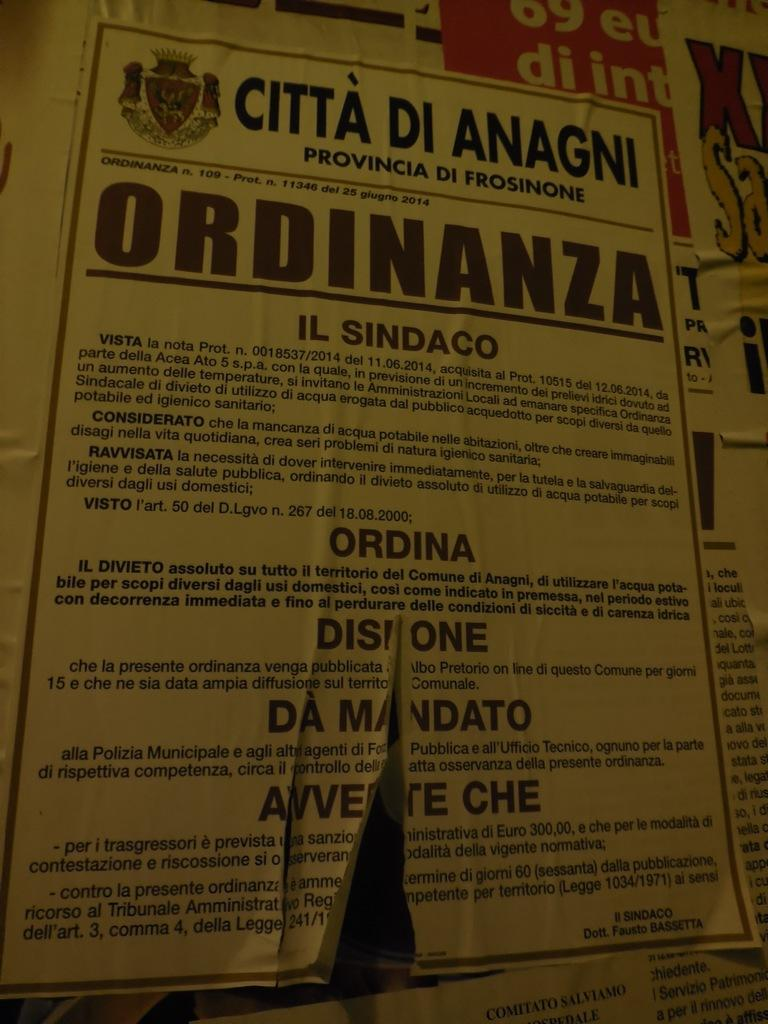<image>
Summarize the visual content of the image. A information sheet on a bulliton board for CITTA DI ANAAGNI. 